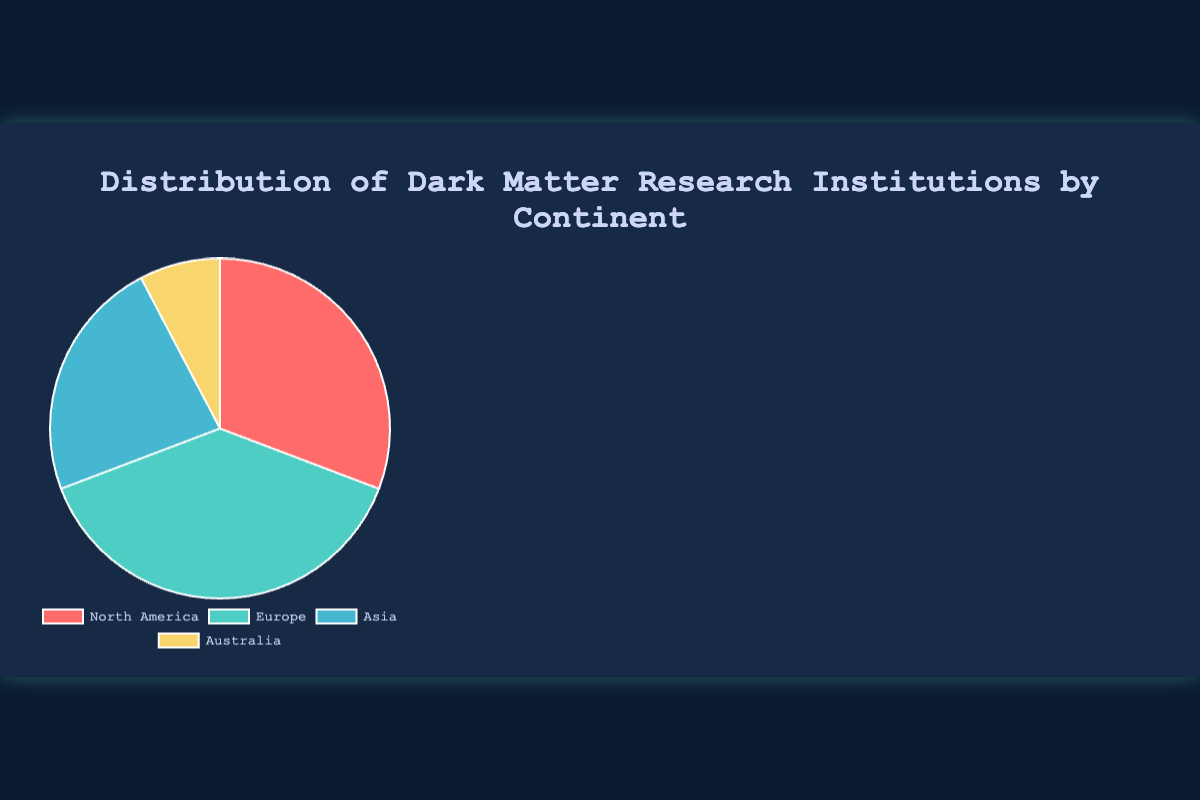What is the total number of dark matter research institutions worldwide? Sum the numbers of institutions in North America (20), Europe (25), Asia (15), and Australia (5). Total = 20 + 25 + 15 + 5 = 65
Answer: 65 Which continent has the most dark matter research institutions? The figure shows that Europe (25 institutions) has the most among the given continents
Answer: Europe How many more dark matter research institutions does Europe have compared to Asia? Subtract the number of institutions in Asia (15) from the number in Europe (25). 25 - 15 = 10
Answer: 10 What fraction of the total dark matter research institutions are located in North America? Divide the number of institutions in North America (20) by the total number of institutions (65). 20/65 ≈ 0.3077
Answer: Approximately 0.31 If you combine the institutions in North America and Australia, what percentage do they account for out of the total? Add the institutions in North America (20) and Australia (5) to get 25. Then divide by the total (65) and multiply by 100. (25/65) * 100 ≈ 38.46%
Answer: Approximately 38.46% What is the difference in the number of institutions between the continent with the most and the continent with the fewest institutions? Europe has the most institutions (25) and Australia has the fewest (5). The difference is 25 - 5 = 20
Answer: 20 Which color represents the institutions in Asia on the pie chart? The visual representation shows Asia is colored in blue according to the data.
Answer: Blue Looking at the continental distribution, which continent accounts for the smallest portion of dark matter research institutions? Australia has the smallest portion with 5 institutions, which is the least among the continents listed.
Answer: Australia Can you determine the average number of institutions per continent? Sum the institutions (65) and divide by the number of continents (4). 65 / 4 = 16.25
Answer: 16.25 Considering only North America and Europe, what is the ratio of dark matter research institutions between these two continents? The number of institutions in North America is 20 and in Europe is 25. The ratio 20:25 simplifies to 4:5.
Answer: 4:5 